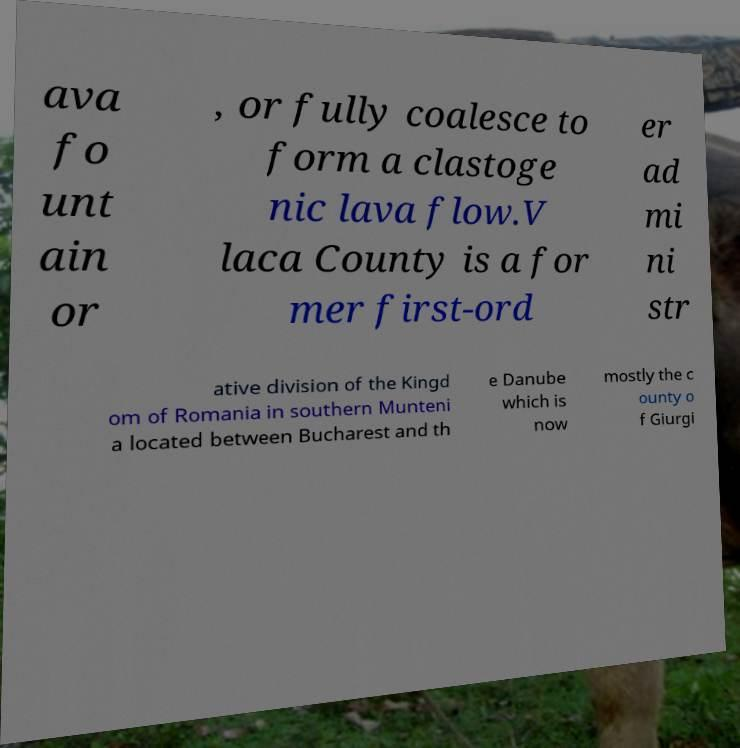Can you read and provide the text displayed in the image?This photo seems to have some interesting text. Can you extract and type it out for me? ava fo unt ain or , or fully coalesce to form a clastoge nic lava flow.V laca County is a for mer first-ord er ad mi ni str ative division of the Kingd om of Romania in southern Munteni a located between Bucharest and th e Danube which is now mostly the c ounty o f Giurgi 